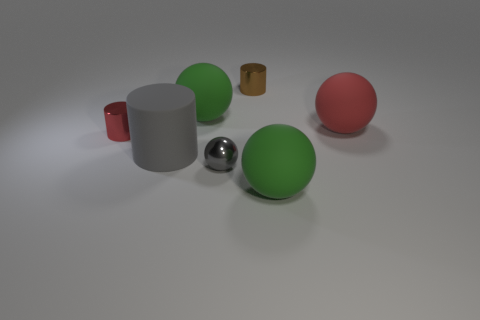Can you describe the lighting and mood of this setup? The lighting in the image is soft and diffused, casting gentle shadows and giving the scene a serene, almost studio-like quality. The mood is quite neutral and calm, with a non-distracting background that emphasizes the objects in the center. The simplicity and cleanliness of the setup invoke a sense of order and minimalistic design. 